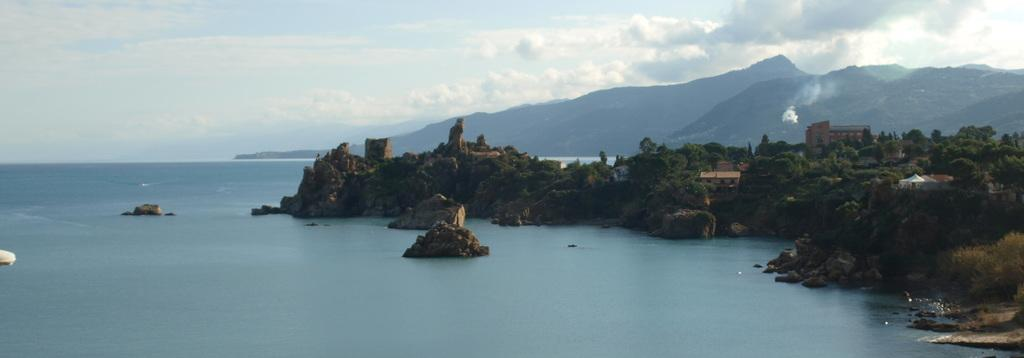What is the primary element visible in the image? There is water in the image. What type of structures can be seen in the image? There are buildings in the image. What type of vegetation is present in the image? There are trees in the image. What type of natural landform is visible in the image? There are mountains in the image. What is visible in the background of the image? The sky is visible in the background of the image. What can be observed in the sky? Clouds are present in the sky. What type of tooth is visible in the image? There is no tooth present in the image. What type of pies are being served in the image? There is no mention of pies in the image. 